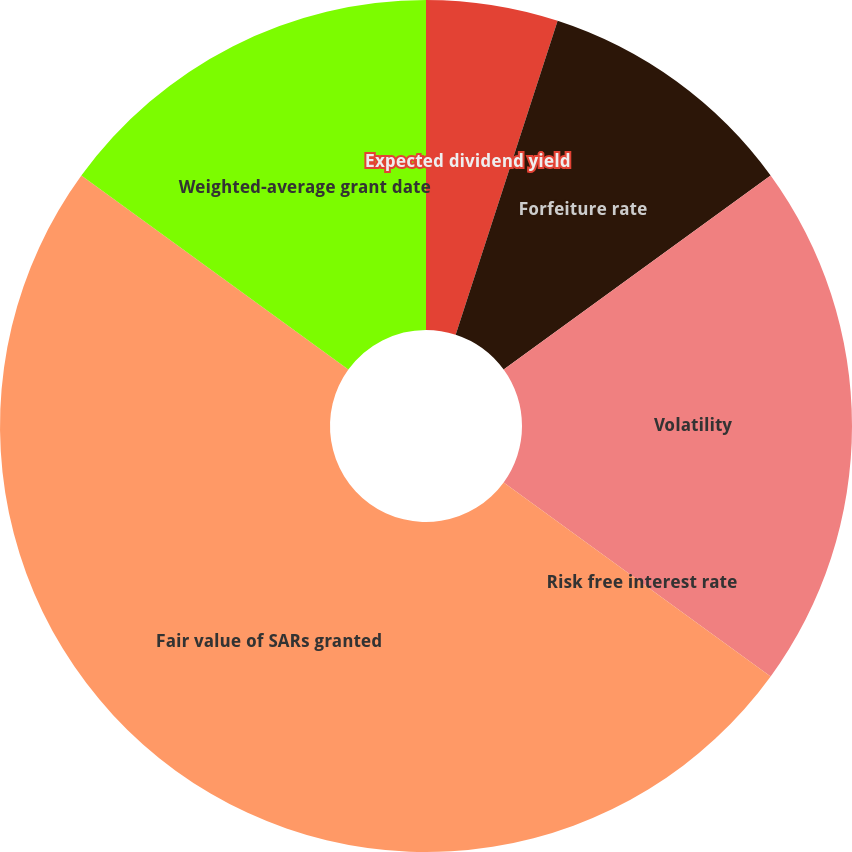<chart> <loc_0><loc_0><loc_500><loc_500><pie_chart><fcel>Expected dividend yield<fcel>Forfeiture rate<fcel>Volatility<fcel>Risk free interest rate<fcel>Fair value of SARs granted<fcel>Weighted-average grant date<nl><fcel>5.0%<fcel>10.0%<fcel>20.0%<fcel>0.0%<fcel>50.0%<fcel>15.0%<nl></chart> 